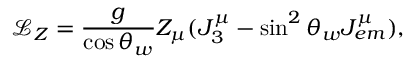Convert formula to latex. <formula><loc_0><loc_0><loc_500><loc_500>\mathcal { L } _ { Z } = \frac { g } { \cos \theta _ { w } } Z _ { \mu } ( J _ { 3 } ^ { \mu } - \sin ^ { 2 } \theta _ { w } J _ { e m } ^ { \mu } ) ,</formula> 